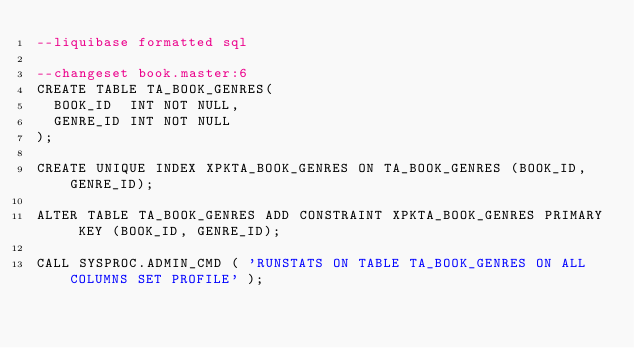Convert code to text. <code><loc_0><loc_0><loc_500><loc_500><_SQL_>--liquibase formatted sql

--changeset book.master:6
CREATE TABLE TA_BOOK_GENRES(
  BOOK_ID  INT NOT NULL, 
  GENRE_ID INT NOT NULL
);

CREATE UNIQUE INDEX XPKTA_BOOK_GENRES ON TA_BOOK_GENRES (BOOK_ID, GENRE_ID);

ALTER TABLE TA_BOOK_GENRES ADD CONSTRAINT XPKTA_BOOK_GENRES PRIMARY KEY (BOOK_ID, GENRE_ID);

CALL SYSPROC.ADMIN_CMD ( 'RUNSTATS ON TABLE TA_BOOK_GENRES ON ALL COLUMNS SET PROFILE' );
</code> 